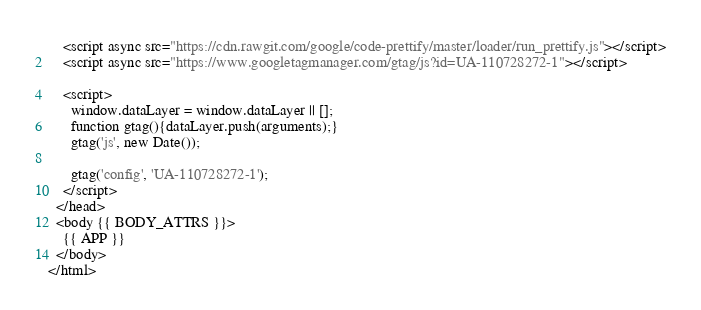Convert code to text. <code><loc_0><loc_0><loc_500><loc_500><_HTML_>    <script async src="https://cdn.rawgit.com/google/code-prettify/master/loader/run_prettify.js"></script>
    <script async src="https://www.googletagmanager.com/gtag/js?id=UA-110728272-1"></script>
 
    <script>
      window.dataLayer = window.dataLayer || [];
      function gtag(){dataLayer.push(arguments);}
      gtag('js', new Date());

      gtag('config', 'UA-110728272-1');
    </script>
  </head>
  <body {{ BODY_ATTRS }}>
    {{ APP }}
  </body>
</html>
</code> 